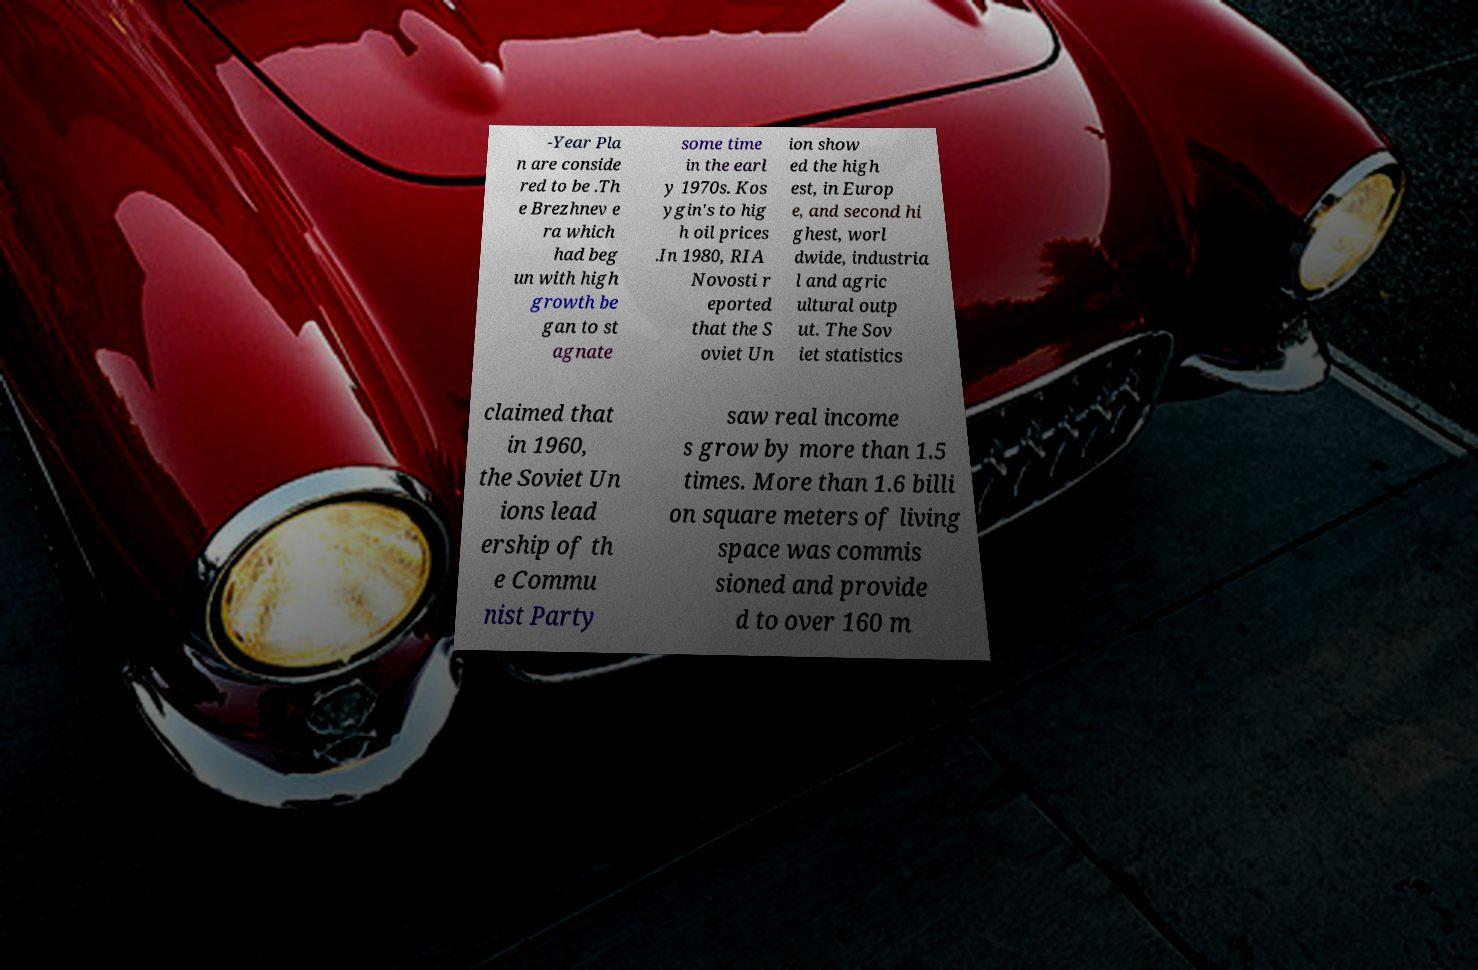Please identify and transcribe the text found in this image. -Year Pla n are conside red to be .Th e Brezhnev e ra which had beg un with high growth be gan to st agnate some time in the earl y 1970s. Kos ygin's to hig h oil prices .In 1980, RIA Novosti r eported that the S oviet Un ion show ed the high est, in Europ e, and second hi ghest, worl dwide, industria l and agric ultural outp ut. The Sov iet statistics claimed that in 1960, the Soviet Un ions lead ership of th e Commu nist Party saw real income s grow by more than 1.5 times. More than 1.6 billi on square meters of living space was commis sioned and provide d to over 160 m 